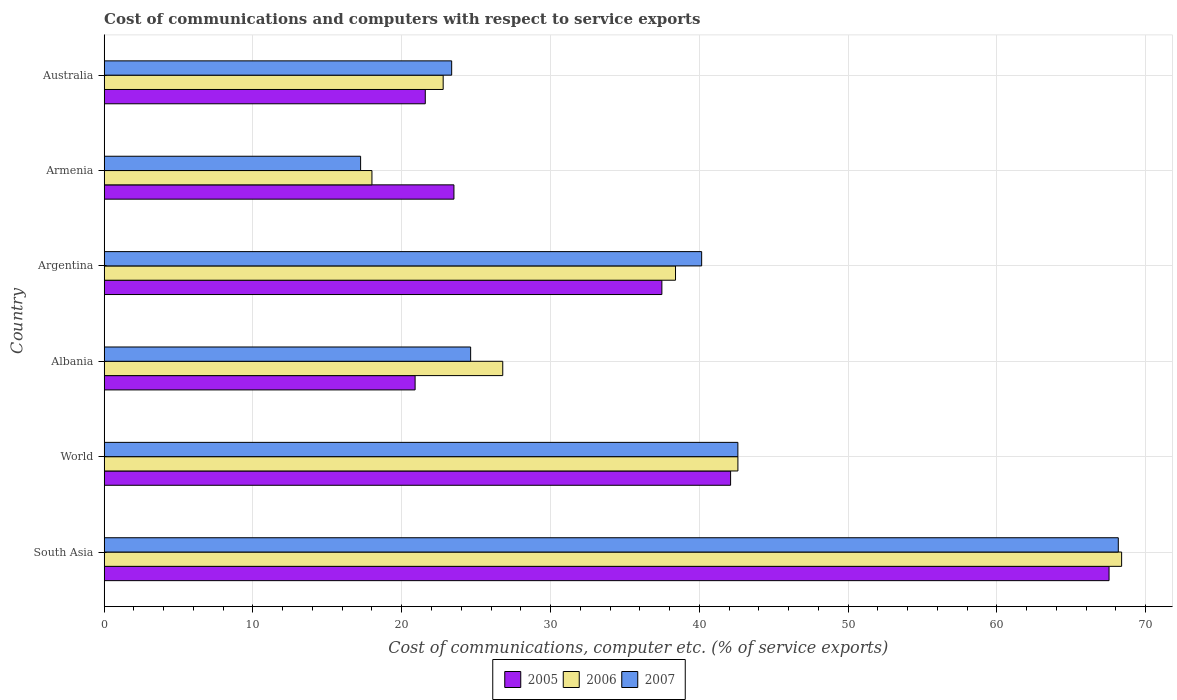Are the number of bars on each tick of the Y-axis equal?
Offer a very short reply. Yes. How many bars are there on the 5th tick from the bottom?
Give a very brief answer. 3. What is the label of the 4th group of bars from the top?
Your answer should be very brief. Albania. In how many cases, is the number of bars for a given country not equal to the number of legend labels?
Provide a short and direct response. 0. What is the cost of communications and computers in 2005 in World?
Provide a succinct answer. 42.1. Across all countries, what is the maximum cost of communications and computers in 2007?
Offer a very short reply. 68.16. Across all countries, what is the minimum cost of communications and computers in 2006?
Your answer should be compact. 18. In which country was the cost of communications and computers in 2007 minimum?
Give a very brief answer. Armenia. What is the total cost of communications and computers in 2005 in the graph?
Offer a very short reply. 213.12. What is the difference between the cost of communications and computers in 2007 in Argentina and that in Armenia?
Keep it short and to the point. 22.92. What is the difference between the cost of communications and computers in 2006 in Argentina and the cost of communications and computers in 2007 in Armenia?
Ensure brevity in your answer.  21.17. What is the average cost of communications and computers in 2006 per country?
Provide a succinct answer. 36.16. What is the difference between the cost of communications and computers in 2006 and cost of communications and computers in 2007 in Armenia?
Provide a short and direct response. 0.76. In how many countries, is the cost of communications and computers in 2006 greater than 38 %?
Your response must be concise. 3. What is the ratio of the cost of communications and computers in 2006 in Armenia to that in Australia?
Keep it short and to the point. 0.79. Is the cost of communications and computers in 2006 in Albania less than that in World?
Make the answer very short. Yes. Is the difference between the cost of communications and computers in 2006 in Argentina and Armenia greater than the difference between the cost of communications and computers in 2007 in Argentina and Armenia?
Your answer should be very brief. No. What is the difference between the highest and the second highest cost of communications and computers in 2005?
Your answer should be very brief. 25.44. What is the difference between the highest and the lowest cost of communications and computers in 2007?
Make the answer very short. 50.92. What does the 2nd bar from the top in Argentina represents?
Offer a terse response. 2006. What does the 1st bar from the bottom in World represents?
Make the answer very short. 2005. Is it the case that in every country, the sum of the cost of communications and computers in 2005 and cost of communications and computers in 2006 is greater than the cost of communications and computers in 2007?
Your answer should be compact. Yes. Are all the bars in the graph horizontal?
Provide a short and direct response. Yes. How many countries are there in the graph?
Your response must be concise. 6. What is the difference between two consecutive major ticks on the X-axis?
Your answer should be very brief. 10. Where does the legend appear in the graph?
Offer a terse response. Bottom center. What is the title of the graph?
Your answer should be compact. Cost of communications and computers with respect to service exports. Does "1969" appear as one of the legend labels in the graph?
Keep it short and to the point. No. What is the label or title of the X-axis?
Offer a very short reply. Cost of communications, computer etc. (% of service exports). What is the Cost of communications, computer etc. (% of service exports) in 2005 in South Asia?
Your response must be concise. 67.54. What is the Cost of communications, computer etc. (% of service exports) of 2006 in South Asia?
Your answer should be very brief. 68.39. What is the Cost of communications, computer etc. (% of service exports) of 2007 in South Asia?
Ensure brevity in your answer.  68.16. What is the Cost of communications, computer etc. (% of service exports) of 2005 in World?
Your answer should be compact. 42.1. What is the Cost of communications, computer etc. (% of service exports) in 2006 in World?
Provide a succinct answer. 42.59. What is the Cost of communications, computer etc. (% of service exports) in 2007 in World?
Offer a very short reply. 42.59. What is the Cost of communications, computer etc. (% of service exports) in 2005 in Albania?
Give a very brief answer. 20.9. What is the Cost of communications, computer etc. (% of service exports) of 2006 in Albania?
Provide a short and direct response. 26.79. What is the Cost of communications, computer etc. (% of service exports) in 2007 in Albania?
Offer a very short reply. 24.63. What is the Cost of communications, computer etc. (% of service exports) in 2005 in Argentina?
Give a very brief answer. 37.49. What is the Cost of communications, computer etc. (% of service exports) of 2006 in Argentina?
Offer a very short reply. 38.4. What is the Cost of communications, computer etc. (% of service exports) in 2007 in Argentina?
Your answer should be compact. 40.16. What is the Cost of communications, computer etc. (% of service exports) in 2005 in Armenia?
Provide a short and direct response. 23.51. What is the Cost of communications, computer etc. (% of service exports) in 2006 in Armenia?
Give a very brief answer. 18. What is the Cost of communications, computer etc. (% of service exports) in 2007 in Armenia?
Provide a succinct answer. 17.24. What is the Cost of communications, computer etc. (% of service exports) in 2005 in Australia?
Ensure brevity in your answer.  21.58. What is the Cost of communications, computer etc. (% of service exports) in 2006 in Australia?
Offer a very short reply. 22.79. What is the Cost of communications, computer etc. (% of service exports) in 2007 in Australia?
Offer a very short reply. 23.36. Across all countries, what is the maximum Cost of communications, computer etc. (% of service exports) of 2005?
Your response must be concise. 67.54. Across all countries, what is the maximum Cost of communications, computer etc. (% of service exports) in 2006?
Your answer should be compact. 68.39. Across all countries, what is the maximum Cost of communications, computer etc. (% of service exports) in 2007?
Give a very brief answer. 68.16. Across all countries, what is the minimum Cost of communications, computer etc. (% of service exports) in 2005?
Keep it short and to the point. 20.9. Across all countries, what is the minimum Cost of communications, computer etc. (% of service exports) of 2006?
Provide a succinct answer. 18. Across all countries, what is the minimum Cost of communications, computer etc. (% of service exports) of 2007?
Your answer should be compact. 17.24. What is the total Cost of communications, computer etc. (% of service exports) in 2005 in the graph?
Offer a very short reply. 213.12. What is the total Cost of communications, computer etc. (% of service exports) of 2006 in the graph?
Ensure brevity in your answer.  216.96. What is the total Cost of communications, computer etc. (% of service exports) of 2007 in the graph?
Give a very brief answer. 216.14. What is the difference between the Cost of communications, computer etc. (% of service exports) of 2005 in South Asia and that in World?
Keep it short and to the point. 25.44. What is the difference between the Cost of communications, computer etc. (% of service exports) of 2006 in South Asia and that in World?
Offer a terse response. 25.79. What is the difference between the Cost of communications, computer etc. (% of service exports) of 2007 in South Asia and that in World?
Provide a short and direct response. 25.57. What is the difference between the Cost of communications, computer etc. (% of service exports) of 2005 in South Asia and that in Albania?
Your answer should be compact. 46.64. What is the difference between the Cost of communications, computer etc. (% of service exports) in 2006 in South Asia and that in Albania?
Provide a succinct answer. 41.59. What is the difference between the Cost of communications, computer etc. (% of service exports) in 2007 in South Asia and that in Albania?
Make the answer very short. 43.53. What is the difference between the Cost of communications, computer etc. (% of service exports) in 2005 in South Asia and that in Argentina?
Provide a succinct answer. 30.06. What is the difference between the Cost of communications, computer etc. (% of service exports) in 2006 in South Asia and that in Argentina?
Provide a succinct answer. 29.98. What is the difference between the Cost of communications, computer etc. (% of service exports) of 2007 in South Asia and that in Argentina?
Give a very brief answer. 28. What is the difference between the Cost of communications, computer etc. (% of service exports) in 2005 in South Asia and that in Armenia?
Provide a succinct answer. 44.03. What is the difference between the Cost of communications, computer etc. (% of service exports) in 2006 in South Asia and that in Armenia?
Your answer should be compact. 50.39. What is the difference between the Cost of communications, computer etc. (% of service exports) of 2007 in South Asia and that in Armenia?
Ensure brevity in your answer.  50.92. What is the difference between the Cost of communications, computer etc. (% of service exports) in 2005 in South Asia and that in Australia?
Keep it short and to the point. 45.96. What is the difference between the Cost of communications, computer etc. (% of service exports) in 2006 in South Asia and that in Australia?
Offer a very short reply. 45.6. What is the difference between the Cost of communications, computer etc. (% of service exports) in 2007 in South Asia and that in Australia?
Provide a short and direct response. 44.8. What is the difference between the Cost of communications, computer etc. (% of service exports) of 2005 in World and that in Albania?
Offer a terse response. 21.2. What is the difference between the Cost of communications, computer etc. (% of service exports) in 2006 in World and that in Albania?
Ensure brevity in your answer.  15.8. What is the difference between the Cost of communications, computer etc. (% of service exports) in 2007 in World and that in Albania?
Your answer should be very brief. 17.96. What is the difference between the Cost of communications, computer etc. (% of service exports) in 2005 in World and that in Argentina?
Give a very brief answer. 4.62. What is the difference between the Cost of communications, computer etc. (% of service exports) of 2006 in World and that in Argentina?
Provide a succinct answer. 4.19. What is the difference between the Cost of communications, computer etc. (% of service exports) of 2007 in World and that in Argentina?
Make the answer very short. 2.43. What is the difference between the Cost of communications, computer etc. (% of service exports) of 2005 in World and that in Armenia?
Your response must be concise. 18.59. What is the difference between the Cost of communications, computer etc. (% of service exports) of 2006 in World and that in Armenia?
Provide a succinct answer. 24.6. What is the difference between the Cost of communications, computer etc. (% of service exports) in 2007 in World and that in Armenia?
Make the answer very short. 25.36. What is the difference between the Cost of communications, computer etc. (% of service exports) in 2005 in World and that in Australia?
Keep it short and to the point. 20.52. What is the difference between the Cost of communications, computer etc. (% of service exports) in 2006 in World and that in Australia?
Offer a terse response. 19.81. What is the difference between the Cost of communications, computer etc. (% of service exports) of 2007 in World and that in Australia?
Provide a succinct answer. 19.24. What is the difference between the Cost of communications, computer etc. (% of service exports) in 2005 in Albania and that in Argentina?
Your answer should be compact. -16.59. What is the difference between the Cost of communications, computer etc. (% of service exports) in 2006 in Albania and that in Argentina?
Your response must be concise. -11.61. What is the difference between the Cost of communications, computer etc. (% of service exports) of 2007 in Albania and that in Argentina?
Provide a succinct answer. -15.53. What is the difference between the Cost of communications, computer etc. (% of service exports) of 2005 in Albania and that in Armenia?
Your response must be concise. -2.61. What is the difference between the Cost of communications, computer etc. (% of service exports) of 2006 in Albania and that in Armenia?
Your answer should be very brief. 8.79. What is the difference between the Cost of communications, computer etc. (% of service exports) of 2007 in Albania and that in Armenia?
Your answer should be compact. 7.39. What is the difference between the Cost of communications, computer etc. (% of service exports) in 2005 in Albania and that in Australia?
Your answer should be very brief. -0.68. What is the difference between the Cost of communications, computer etc. (% of service exports) of 2006 in Albania and that in Australia?
Provide a succinct answer. 4. What is the difference between the Cost of communications, computer etc. (% of service exports) in 2007 in Albania and that in Australia?
Ensure brevity in your answer.  1.27. What is the difference between the Cost of communications, computer etc. (% of service exports) of 2005 in Argentina and that in Armenia?
Offer a terse response. 13.98. What is the difference between the Cost of communications, computer etc. (% of service exports) of 2006 in Argentina and that in Armenia?
Your answer should be very brief. 20.4. What is the difference between the Cost of communications, computer etc. (% of service exports) of 2007 in Argentina and that in Armenia?
Provide a short and direct response. 22.92. What is the difference between the Cost of communications, computer etc. (% of service exports) in 2005 in Argentina and that in Australia?
Make the answer very short. 15.9. What is the difference between the Cost of communications, computer etc. (% of service exports) in 2006 in Argentina and that in Australia?
Offer a very short reply. 15.62. What is the difference between the Cost of communications, computer etc. (% of service exports) of 2007 in Argentina and that in Australia?
Your response must be concise. 16.8. What is the difference between the Cost of communications, computer etc. (% of service exports) of 2005 in Armenia and that in Australia?
Keep it short and to the point. 1.93. What is the difference between the Cost of communications, computer etc. (% of service exports) in 2006 in Armenia and that in Australia?
Provide a short and direct response. -4.79. What is the difference between the Cost of communications, computer etc. (% of service exports) of 2007 in Armenia and that in Australia?
Offer a very short reply. -6.12. What is the difference between the Cost of communications, computer etc. (% of service exports) in 2005 in South Asia and the Cost of communications, computer etc. (% of service exports) in 2006 in World?
Your answer should be very brief. 24.95. What is the difference between the Cost of communications, computer etc. (% of service exports) of 2005 in South Asia and the Cost of communications, computer etc. (% of service exports) of 2007 in World?
Your answer should be very brief. 24.95. What is the difference between the Cost of communications, computer etc. (% of service exports) in 2006 in South Asia and the Cost of communications, computer etc. (% of service exports) in 2007 in World?
Provide a succinct answer. 25.79. What is the difference between the Cost of communications, computer etc. (% of service exports) in 2005 in South Asia and the Cost of communications, computer etc. (% of service exports) in 2006 in Albania?
Your answer should be very brief. 40.75. What is the difference between the Cost of communications, computer etc. (% of service exports) of 2005 in South Asia and the Cost of communications, computer etc. (% of service exports) of 2007 in Albania?
Offer a terse response. 42.91. What is the difference between the Cost of communications, computer etc. (% of service exports) in 2006 in South Asia and the Cost of communications, computer etc. (% of service exports) in 2007 in Albania?
Keep it short and to the point. 43.75. What is the difference between the Cost of communications, computer etc. (% of service exports) in 2005 in South Asia and the Cost of communications, computer etc. (% of service exports) in 2006 in Argentina?
Your answer should be compact. 29.14. What is the difference between the Cost of communications, computer etc. (% of service exports) in 2005 in South Asia and the Cost of communications, computer etc. (% of service exports) in 2007 in Argentina?
Offer a terse response. 27.38. What is the difference between the Cost of communications, computer etc. (% of service exports) of 2006 in South Asia and the Cost of communications, computer etc. (% of service exports) of 2007 in Argentina?
Give a very brief answer. 28.23. What is the difference between the Cost of communications, computer etc. (% of service exports) in 2005 in South Asia and the Cost of communications, computer etc. (% of service exports) in 2006 in Armenia?
Provide a succinct answer. 49.54. What is the difference between the Cost of communications, computer etc. (% of service exports) in 2005 in South Asia and the Cost of communications, computer etc. (% of service exports) in 2007 in Armenia?
Your response must be concise. 50.3. What is the difference between the Cost of communications, computer etc. (% of service exports) in 2006 in South Asia and the Cost of communications, computer etc. (% of service exports) in 2007 in Armenia?
Offer a very short reply. 51.15. What is the difference between the Cost of communications, computer etc. (% of service exports) of 2005 in South Asia and the Cost of communications, computer etc. (% of service exports) of 2006 in Australia?
Make the answer very short. 44.75. What is the difference between the Cost of communications, computer etc. (% of service exports) of 2005 in South Asia and the Cost of communications, computer etc. (% of service exports) of 2007 in Australia?
Your response must be concise. 44.18. What is the difference between the Cost of communications, computer etc. (% of service exports) in 2006 in South Asia and the Cost of communications, computer etc. (% of service exports) in 2007 in Australia?
Your answer should be very brief. 45.03. What is the difference between the Cost of communications, computer etc. (% of service exports) of 2005 in World and the Cost of communications, computer etc. (% of service exports) of 2006 in Albania?
Make the answer very short. 15.31. What is the difference between the Cost of communications, computer etc. (% of service exports) in 2005 in World and the Cost of communications, computer etc. (% of service exports) in 2007 in Albania?
Keep it short and to the point. 17.47. What is the difference between the Cost of communications, computer etc. (% of service exports) in 2006 in World and the Cost of communications, computer etc. (% of service exports) in 2007 in Albania?
Give a very brief answer. 17.96. What is the difference between the Cost of communications, computer etc. (% of service exports) of 2005 in World and the Cost of communications, computer etc. (% of service exports) of 2006 in Argentina?
Provide a short and direct response. 3.7. What is the difference between the Cost of communications, computer etc. (% of service exports) in 2005 in World and the Cost of communications, computer etc. (% of service exports) in 2007 in Argentina?
Keep it short and to the point. 1.95. What is the difference between the Cost of communications, computer etc. (% of service exports) in 2006 in World and the Cost of communications, computer etc. (% of service exports) in 2007 in Argentina?
Offer a terse response. 2.44. What is the difference between the Cost of communications, computer etc. (% of service exports) of 2005 in World and the Cost of communications, computer etc. (% of service exports) of 2006 in Armenia?
Provide a short and direct response. 24.11. What is the difference between the Cost of communications, computer etc. (% of service exports) of 2005 in World and the Cost of communications, computer etc. (% of service exports) of 2007 in Armenia?
Offer a terse response. 24.87. What is the difference between the Cost of communications, computer etc. (% of service exports) of 2006 in World and the Cost of communications, computer etc. (% of service exports) of 2007 in Armenia?
Offer a terse response. 25.36. What is the difference between the Cost of communications, computer etc. (% of service exports) of 2005 in World and the Cost of communications, computer etc. (% of service exports) of 2006 in Australia?
Make the answer very short. 19.32. What is the difference between the Cost of communications, computer etc. (% of service exports) of 2005 in World and the Cost of communications, computer etc. (% of service exports) of 2007 in Australia?
Ensure brevity in your answer.  18.75. What is the difference between the Cost of communications, computer etc. (% of service exports) of 2006 in World and the Cost of communications, computer etc. (% of service exports) of 2007 in Australia?
Provide a short and direct response. 19.24. What is the difference between the Cost of communications, computer etc. (% of service exports) of 2005 in Albania and the Cost of communications, computer etc. (% of service exports) of 2006 in Argentina?
Your answer should be compact. -17.5. What is the difference between the Cost of communications, computer etc. (% of service exports) in 2005 in Albania and the Cost of communications, computer etc. (% of service exports) in 2007 in Argentina?
Your response must be concise. -19.26. What is the difference between the Cost of communications, computer etc. (% of service exports) of 2006 in Albania and the Cost of communications, computer etc. (% of service exports) of 2007 in Argentina?
Offer a very short reply. -13.37. What is the difference between the Cost of communications, computer etc. (% of service exports) of 2005 in Albania and the Cost of communications, computer etc. (% of service exports) of 2006 in Armenia?
Make the answer very short. 2.9. What is the difference between the Cost of communications, computer etc. (% of service exports) in 2005 in Albania and the Cost of communications, computer etc. (% of service exports) in 2007 in Armenia?
Keep it short and to the point. 3.66. What is the difference between the Cost of communications, computer etc. (% of service exports) of 2006 in Albania and the Cost of communications, computer etc. (% of service exports) of 2007 in Armenia?
Give a very brief answer. 9.55. What is the difference between the Cost of communications, computer etc. (% of service exports) of 2005 in Albania and the Cost of communications, computer etc. (% of service exports) of 2006 in Australia?
Provide a succinct answer. -1.89. What is the difference between the Cost of communications, computer etc. (% of service exports) of 2005 in Albania and the Cost of communications, computer etc. (% of service exports) of 2007 in Australia?
Your answer should be very brief. -2.46. What is the difference between the Cost of communications, computer etc. (% of service exports) of 2006 in Albania and the Cost of communications, computer etc. (% of service exports) of 2007 in Australia?
Provide a short and direct response. 3.43. What is the difference between the Cost of communications, computer etc. (% of service exports) of 2005 in Argentina and the Cost of communications, computer etc. (% of service exports) of 2006 in Armenia?
Offer a terse response. 19.49. What is the difference between the Cost of communications, computer etc. (% of service exports) in 2005 in Argentina and the Cost of communications, computer etc. (% of service exports) in 2007 in Armenia?
Provide a short and direct response. 20.25. What is the difference between the Cost of communications, computer etc. (% of service exports) in 2006 in Argentina and the Cost of communications, computer etc. (% of service exports) in 2007 in Armenia?
Offer a very short reply. 21.17. What is the difference between the Cost of communications, computer etc. (% of service exports) of 2005 in Argentina and the Cost of communications, computer etc. (% of service exports) of 2006 in Australia?
Your response must be concise. 14.7. What is the difference between the Cost of communications, computer etc. (% of service exports) of 2005 in Argentina and the Cost of communications, computer etc. (% of service exports) of 2007 in Australia?
Your answer should be compact. 14.13. What is the difference between the Cost of communications, computer etc. (% of service exports) of 2006 in Argentina and the Cost of communications, computer etc. (% of service exports) of 2007 in Australia?
Provide a succinct answer. 15.05. What is the difference between the Cost of communications, computer etc. (% of service exports) of 2005 in Armenia and the Cost of communications, computer etc. (% of service exports) of 2006 in Australia?
Your answer should be very brief. 0.72. What is the difference between the Cost of communications, computer etc. (% of service exports) in 2005 in Armenia and the Cost of communications, computer etc. (% of service exports) in 2007 in Australia?
Keep it short and to the point. 0.15. What is the difference between the Cost of communications, computer etc. (% of service exports) of 2006 in Armenia and the Cost of communications, computer etc. (% of service exports) of 2007 in Australia?
Keep it short and to the point. -5.36. What is the average Cost of communications, computer etc. (% of service exports) in 2005 per country?
Provide a succinct answer. 35.52. What is the average Cost of communications, computer etc. (% of service exports) in 2006 per country?
Ensure brevity in your answer.  36.16. What is the average Cost of communications, computer etc. (% of service exports) of 2007 per country?
Your answer should be very brief. 36.02. What is the difference between the Cost of communications, computer etc. (% of service exports) of 2005 and Cost of communications, computer etc. (% of service exports) of 2006 in South Asia?
Keep it short and to the point. -0.84. What is the difference between the Cost of communications, computer etc. (% of service exports) of 2005 and Cost of communications, computer etc. (% of service exports) of 2007 in South Asia?
Make the answer very short. -0.62. What is the difference between the Cost of communications, computer etc. (% of service exports) of 2006 and Cost of communications, computer etc. (% of service exports) of 2007 in South Asia?
Offer a terse response. 0.22. What is the difference between the Cost of communications, computer etc. (% of service exports) of 2005 and Cost of communications, computer etc. (% of service exports) of 2006 in World?
Ensure brevity in your answer.  -0.49. What is the difference between the Cost of communications, computer etc. (% of service exports) of 2005 and Cost of communications, computer etc. (% of service exports) of 2007 in World?
Give a very brief answer. -0.49. What is the difference between the Cost of communications, computer etc. (% of service exports) of 2006 and Cost of communications, computer etc. (% of service exports) of 2007 in World?
Ensure brevity in your answer.  0. What is the difference between the Cost of communications, computer etc. (% of service exports) of 2005 and Cost of communications, computer etc. (% of service exports) of 2006 in Albania?
Provide a succinct answer. -5.89. What is the difference between the Cost of communications, computer etc. (% of service exports) of 2005 and Cost of communications, computer etc. (% of service exports) of 2007 in Albania?
Your answer should be very brief. -3.73. What is the difference between the Cost of communications, computer etc. (% of service exports) of 2006 and Cost of communications, computer etc. (% of service exports) of 2007 in Albania?
Provide a succinct answer. 2.16. What is the difference between the Cost of communications, computer etc. (% of service exports) in 2005 and Cost of communications, computer etc. (% of service exports) in 2006 in Argentina?
Your answer should be very brief. -0.92. What is the difference between the Cost of communications, computer etc. (% of service exports) in 2005 and Cost of communications, computer etc. (% of service exports) in 2007 in Argentina?
Make the answer very short. -2.67. What is the difference between the Cost of communications, computer etc. (% of service exports) in 2006 and Cost of communications, computer etc. (% of service exports) in 2007 in Argentina?
Your response must be concise. -1.76. What is the difference between the Cost of communications, computer etc. (% of service exports) in 2005 and Cost of communications, computer etc. (% of service exports) in 2006 in Armenia?
Make the answer very short. 5.51. What is the difference between the Cost of communications, computer etc. (% of service exports) in 2005 and Cost of communications, computer etc. (% of service exports) in 2007 in Armenia?
Your answer should be very brief. 6.27. What is the difference between the Cost of communications, computer etc. (% of service exports) in 2006 and Cost of communications, computer etc. (% of service exports) in 2007 in Armenia?
Offer a very short reply. 0.76. What is the difference between the Cost of communications, computer etc. (% of service exports) in 2005 and Cost of communications, computer etc. (% of service exports) in 2006 in Australia?
Provide a short and direct response. -1.2. What is the difference between the Cost of communications, computer etc. (% of service exports) of 2005 and Cost of communications, computer etc. (% of service exports) of 2007 in Australia?
Provide a succinct answer. -1.77. What is the difference between the Cost of communications, computer etc. (% of service exports) of 2006 and Cost of communications, computer etc. (% of service exports) of 2007 in Australia?
Your answer should be compact. -0.57. What is the ratio of the Cost of communications, computer etc. (% of service exports) of 2005 in South Asia to that in World?
Your answer should be compact. 1.6. What is the ratio of the Cost of communications, computer etc. (% of service exports) in 2006 in South Asia to that in World?
Your answer should be compact. 1.61. What is the ratio of the Cost of communications, computer etc. (% of service exports) of 2007 in South Asia to that in World?
Make the answer very short. 1.6. What is the ratio of the Cost of communications, computer etc. (% of service exports) of 2005 in South Asia to that in Albania?
Provide a short and direct response. 3.23. What is the ratio of the Cost of communications, computer etc. (% of service exports) in 2006 in South Asia to that in Albania?
Your answer should be very brief. 2.55. What is the ratio of the Cost of communications, computer etc. (% of service exports) of 2007 in South Asia to that in Albania?
Offer a very short reply. 2.77. What is the ratio of the Cost of communications, computer etc. (% of service exports) in 2005 in South Asia to that in Argentina?
Your answer should be compact. 1.8. What is the ratio of the Cost of communications, computer etc. (% of service exports) of 2006 in South Asia to that in Argentina?
Make the answer very short. 1.78. What is the ratio of the Cost of communications, computer etc. (% of service exports) of 2007 in South Asia to that in Argentina?
Offer a very short reply. 1.7. What is the ratio of the Cost of communications, computer etc. (% of service exports) in 2005 in South Asia to that in Armenia?
Your answer should be compact. 2.87. What is the ratio of the Cost of communications, computer etc. (% of service exports) of 2006 in South Asia to that in Armenia?
Offer a terse response. 3.8. What is the ratio of the Cost of communications, computer etc. (% of service exports) in 2007 in South Asia to that in Armenia?
Provide a short and direct response. 3.95. What is the ratio of the Cost of communications, computer etc. (% of service exports) of 2005 in South Asia to that in Australia?
Your answer should be compact. 3.13. What is the ratio of the Cost of communications, computer etc. (% of service exports) in 2006 in South Asia to that in Australia?
Keep it short and to the point. 3. What is the ratio of the Cost of communications, computer etc. (% of service exports) in 2007 in South Asia to that in Australia?
Ensure brevity in your answer.  2.92. What is the ratio of the Cost of communications, computer etc. (% of service exports) of 2005 in World to that in Albania?
Make the answer very short. 2.01. What is the ratio of the Cost of communications, computer etc. (% of service exports) of 2006 in World to that in Albania?
Your answer should be very brief. 1.59. What is the ratio of the Cost of communications, computer etc. (% of service exports) of 2007 in World to that in Albania?
Your answer should be very brief. 1.73. What is the ratio of the Cost of communications, computer etc. (% of service exports) in 2005 in World to that in Argentina?
Your response must be concise. 1.12. What is the ratio of the Cost of communications, computer etc. (% of service exports) in 2006 in World to that in Argentina?
Your response must be concise. 1.11. What is the ratio of the Cost of communications, computer etc. (% of service exports) in 2007 in World to that in Argentina?
Offer a terse response. 1.06. What is the ratio of the Cost of communications, computer etc. (% of service exports) in 2005 in World to that in Armenia?
Your answer should be compact. 1.79. What is the ratio of the Cost of communications, computer etc. (% of service exports) of 2006 in World to that in Armenia?
Keep it short and to the point. 2.37. What is the ratio of the Cost of communications, computer etc. (% of service exports) of 2007 in World to that in Armenia?
Keep it short and to the point. 2.47. What is the ratio of the Cost of communications, computer etc. (% of service exports) of 2005 in World to that in Australia?
Keep it short and to the point. 1.95. What is the ratio of the Cost of communications, computer etc. (% of service exports) in 2006 in World to that in Australia?
Give a very brief answer. 1.87. What is the ratio of the Cost of communications, computer etc. (% of service exports) of 2007 in World to that in Australia?
Offer a terse response. 1.82. What is the ratio of the Cost of communications, computer etc. (% of service exports) of 2005 in Albania to that in Argentina?
Your answer should be compact. 0.56. What is the ratio of the Cost of communications, computer etc. (% of service exports) in 2006 in Albania to that in Argentina?
Offer a terse response. 0.7. What is the ratio of the Cost of communications, computer etc. (% of service exports) in 2007 in Albania to that in Argentina?
Your answer should be compact. 0.61. What is the ratio of the Cost of communications, computer etc. (% of service exports) of 2005 in Albania to that in Armenia?
Give a very brief answer. 0.89. What is the ratio of the Cost of communications, computer etc. (% of service exports) in 2006 in Albania to that in Armenia?
Your answer should be compact. 1.49. What is the ratio of the Cost of communications, computer etc. (% of service exports) in 2007 in Albania to that in Armenia?
Make the answer very short. 1.43. What is the ratio of the Cost of communications, computer etc. (% of service exports) of 2005 in Albania to that in Australia?
Make the answer very short. 0.97. What is the ratio of the Cost of communications, computer etc. (% of service exports) in 2006 in Albania to that in Australia?
Provide a short and direct response. 1.18. What is the ratio of the Cost of communications, computer etc. (% of service exports) of 2007 in Albania to that in Australia?
Your response must be concise. 1.05. What is the ratio of the Cost of communications, computer etc. (% of service exports) in 2005 in Argentina to that in Armenia?
Your answer should be very brief. 1.59. What is the ratio of the Cost of communications, computer etc. (% of service exports) of 2006 in Argentina to that in Armenia?
Give a very brief answer. 2.13. What is the ratio of the Cost of communications, computer etc. (% of service exports) of 2007 in Argentina to that in Armenia?
Offer a terse response. 2.33. What is the ratio of the Cost of communications, computer etc. (% of service exports) in 2005 in Argentina to that in Australia?
Give a very brief answer. 1.74. What is the ratio of the Cost of communications, computer etc. (% of service exports) of 2006 in Argentina to that in Australia?
Offer a very short reply. 1.69. What is the ratio of the Cost of communications, computer etc. (% of service exports) of 2007 in Argentina to that in Australia?
Your response must be concise. 1.72. What is the ratio of the Cost of communications, computer etc. (% of service exports) of 2005 in Armenia to that in Australia?
Ensure brevity in your answer.  1.09. What is the ratio of the Cost of communications, computer etc. (% of service exports) in 2006 in Armenia to that in Australia?
Give a very brief answer. 0.79. What is the ratio of the Cost of communications, computer etc. (% of service exports) in 2007 in Armenia to that in Australia?
Offer a very short reply. 0.74. What is the difference between the highest and the second highest Cost of communications, computer etc. (% of service exports) of 2005?
Offer a terse response. 25.44. What is the difference between the highest and the second highest Cost of communications, computer etc. (% of service exports) of 2006?
Make the answer very short. 25.79. What is the difference between the highest and the second highest Cost of communications, computer etc. (% of service exports) of 2007?
Ensure brevity in your answer.  25.57. What is the difference between the highest and the lowest Cost of communications, computer etc. (% of service exports) in 2005?
Provide a short and direct response. 46.64. What is the difference between the highest and the lowest Cost of communications, computer etc. (% of service exports) of 2006?
Your response must be concise. 50.39. What is the difference between the highest and the lowest Cost of communications, computer etc. (% of service exports) of 2007?
Your answer should be compact. 50.92. 